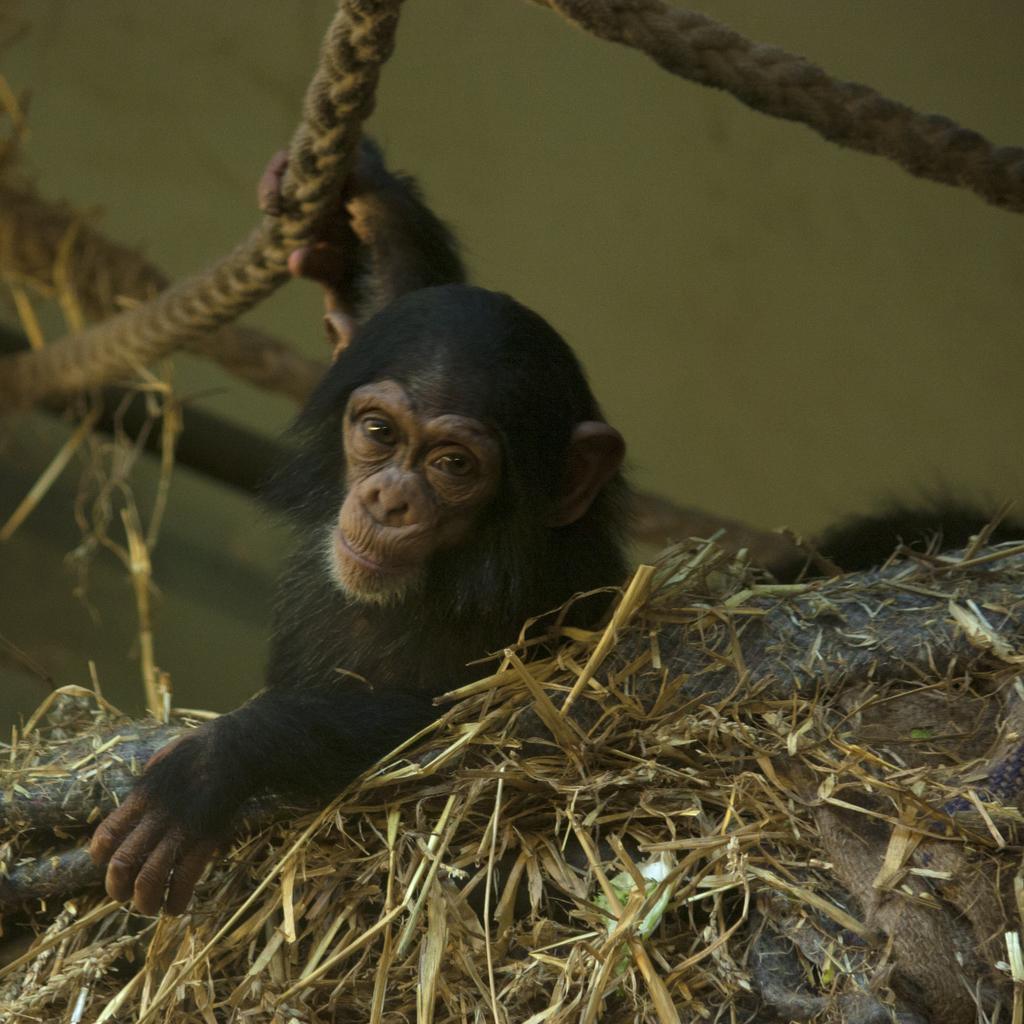In one or two sentences, can you explain what this image depicts? In this image we can see a chimpanzee holding a rope and also we can see the dry grass. 